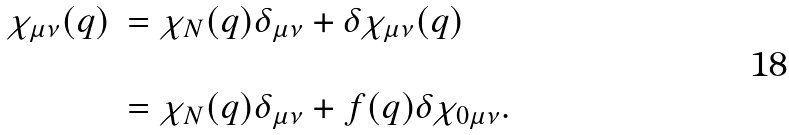Convert formula to latex. <formula><loc_0><loc_0><loc_500><loc_500>\begin{array} { l l } \chi _ { \mu \nu } ( q ) & = \chi _ { N } ( q ) \delta _ { \mu \nu } + \delta \chi _ { \mu \nu } ( q ) \\ & \\ & = \chi _ { N } ( q ) \delta _ { \mu \nu } + f ( q ) \delta \chi _ { 0 \mu \nu } . \\ \end{array}</formula> 